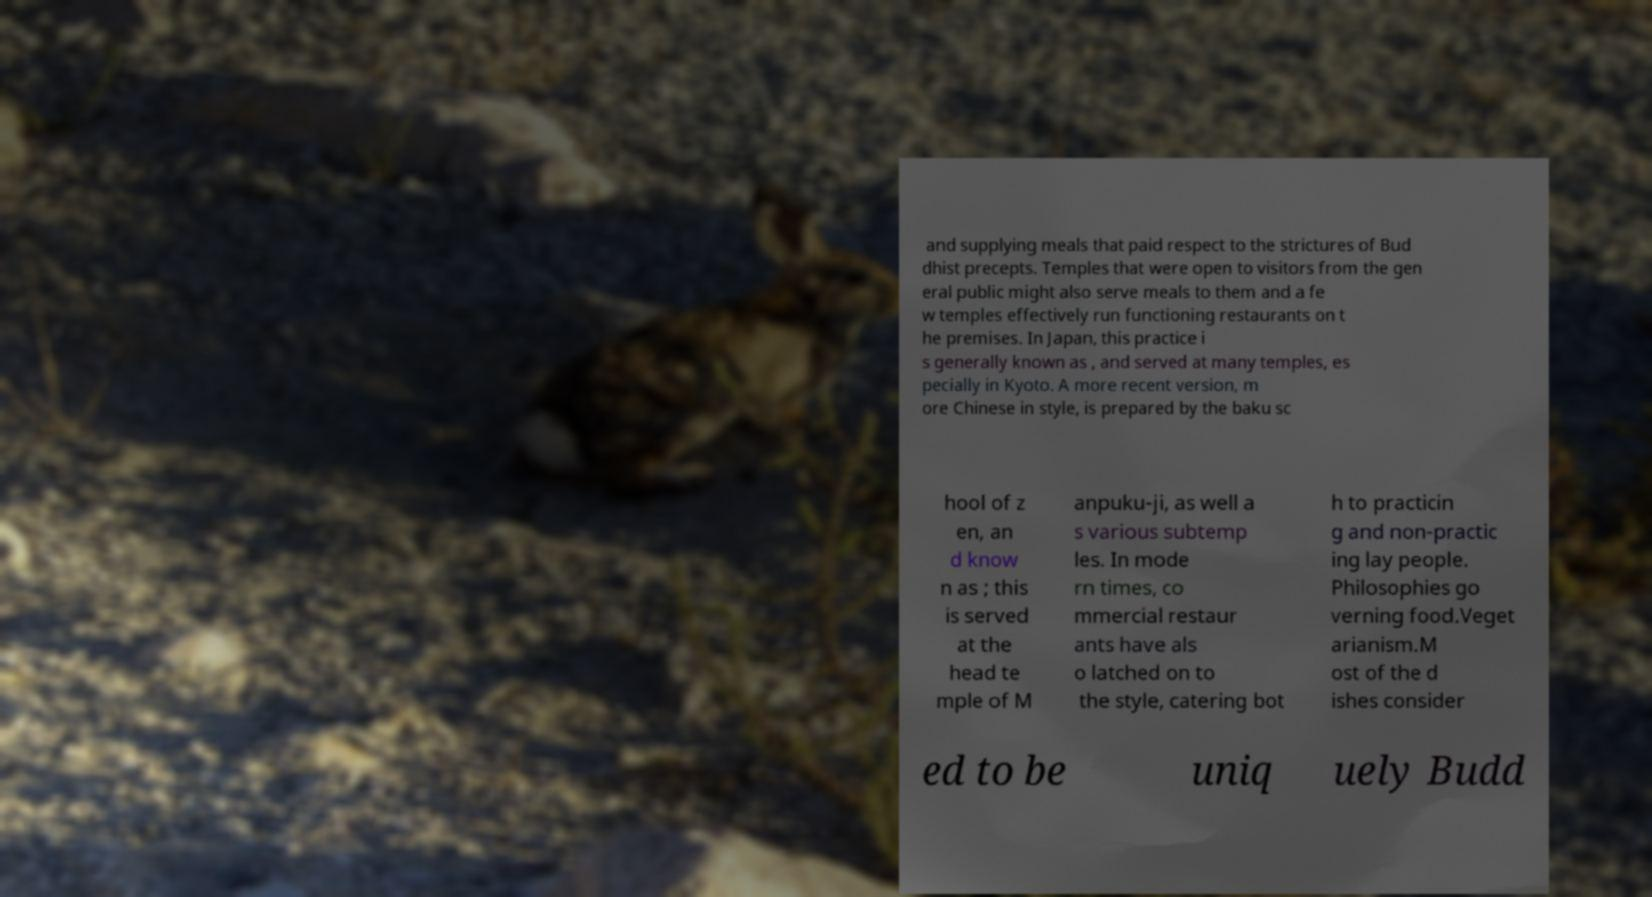Please read and relay the text visible in this image. What does it say? and supplying meals that paid respect to the strictures of Bud dhist precepts. Temples that were open to visitors from the gen eral public might also serve meals to them and a fe w temples effectively run functioning restaurants on t he premises. In Japan, this practice i s generally known as , and served at many temples, es pecially in Kyoto. A more recent version, m ore Chinese in style, is prepared by the baku sc hool of z en, an d know n as ; this is served at the head te mple of M anpuku-ji, as well a s various subtemp les. In mode rn times, co mmercial restaur ants have als o latched on to the style, catering bot h to practicin g and non-practic ing lay people. Philosophies go verning food.Veget arianism.M ost of the d ishes consider ed to be uniq uely Budd 